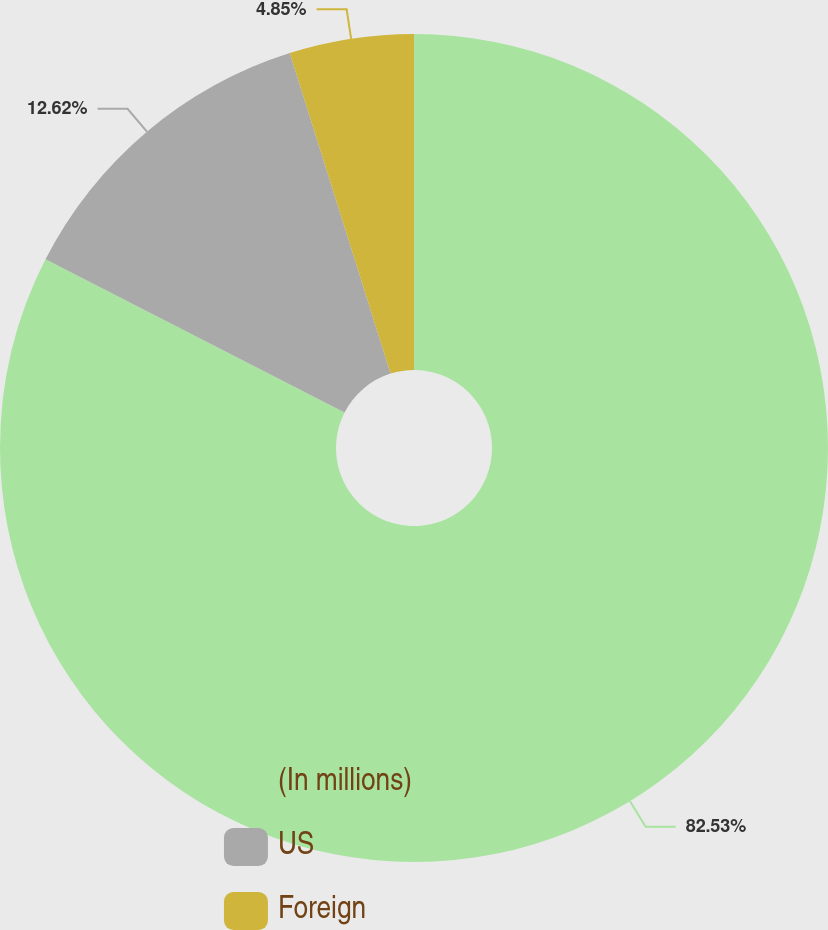<chart> <loc_0><loc_0><loc_500><loc_500><pie_chart><fcel>(In millions)<fcel>US<fcel>Foreign<nl><fcel>82.53%<fcel>12.62%<fcel>4.85%<nl></chart> 